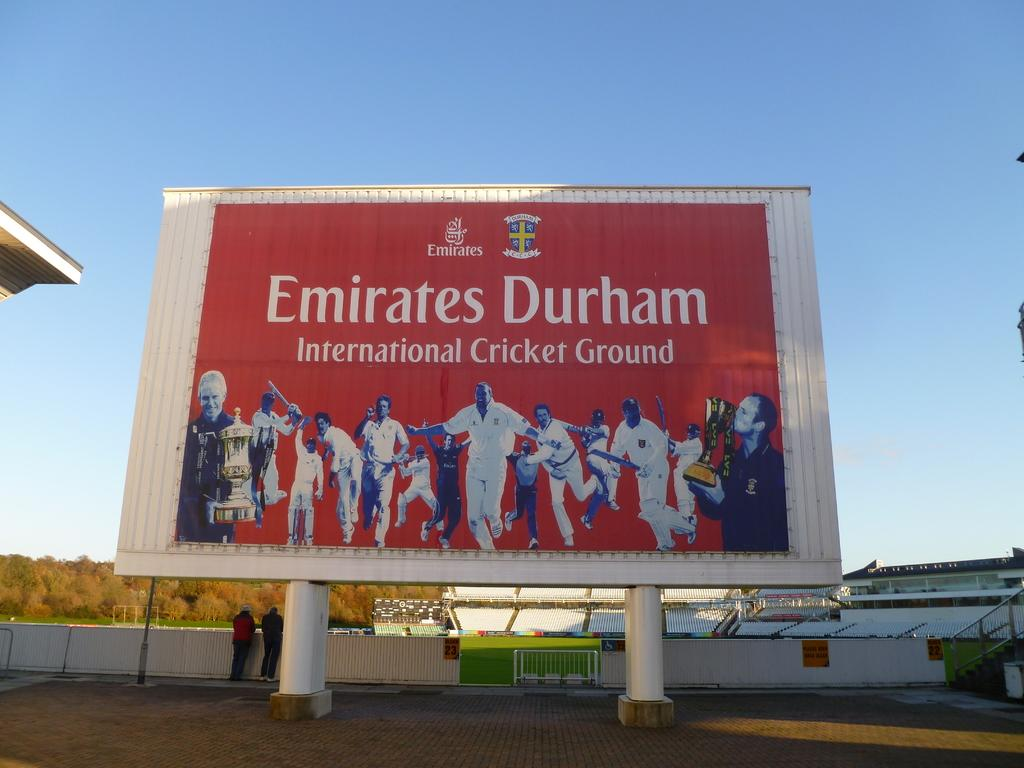<image>
Present a compact description of the photo's key features. a sign for EMIRATES DURHAM is displayed in a lot 